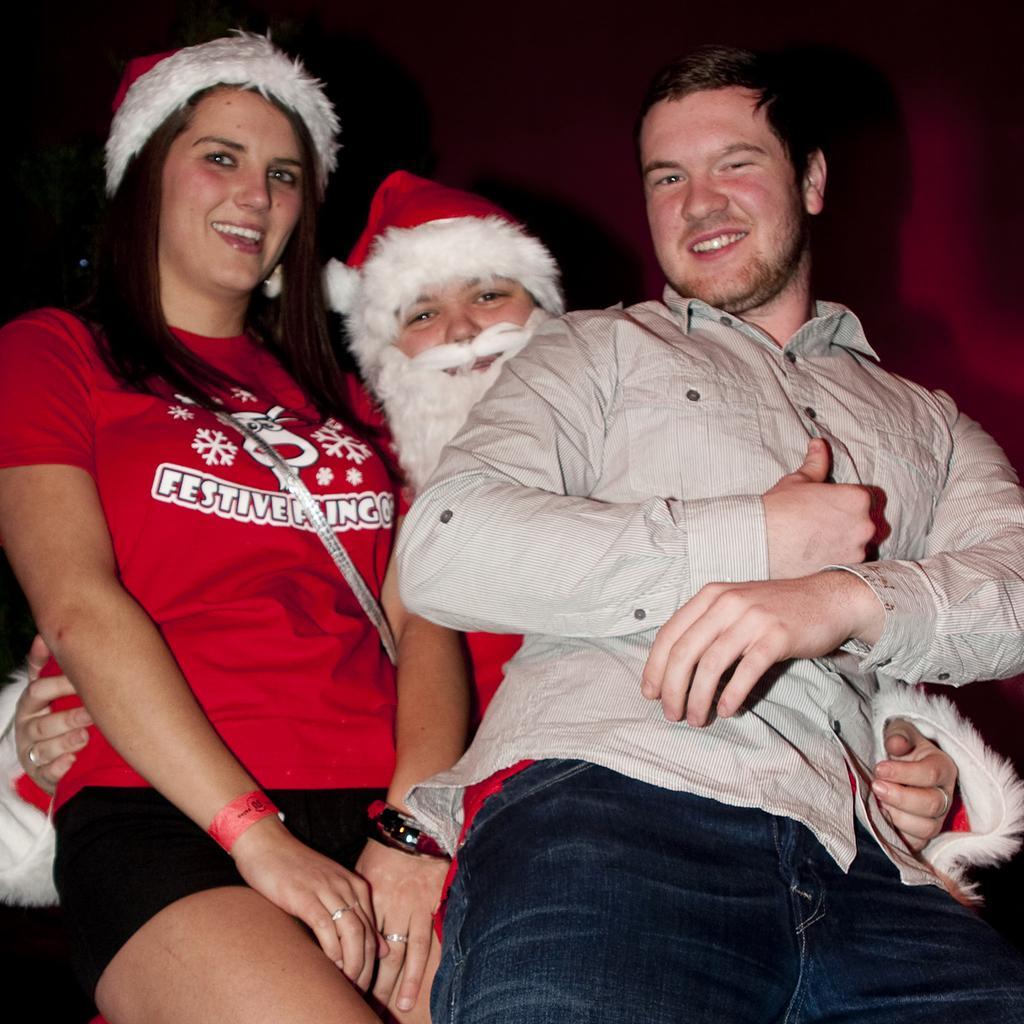Describe this image in one or two sentences. There are people smiling. In the background it is dark. 